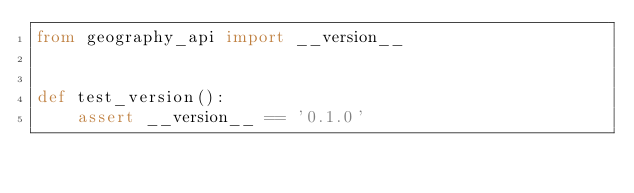<code> <loc_0><loc_0><loc_500><loc_500><_Python_>from geography_api import __version__


def test_version():
    assert __version__ == '0.1.0'
</code> 